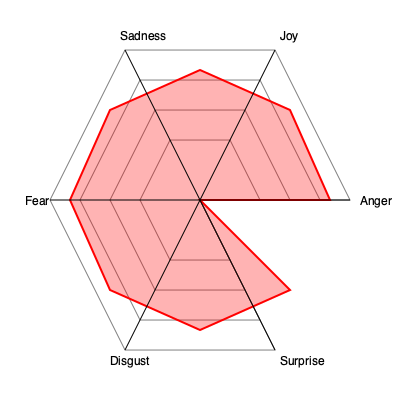Based on the radar chart depicting Kelsey Leigh Miller's emotional range in performances, which emotion does she seem to portray most strongly, and which one appears to be her weakest? To answer this question, we need to analyze the radar chart showing Kelsey Leigh Miller's emotional range in performances:

1. The chart displays six emotions: Anger, Joy, Sadness, Fear, Disgust, and Surprise.
2. Each emotion is represented by an axis extending from the center of the chart.
3. The red polygon indicates the extent of Kelsey's ability to portray each emotion.
4. The further the polygon extends along an axis, the stronger her ability to portray that emotion.

Analyzing the chart:
1. Anger: The polygon extends to the outermost ring, indicating very strong portrayal.
2. Joy: Extends to about 3/4 of the axis, showing good but not maximum ability.
3. Sadness: Reaches almost to the outer ring, indicating strong portrayal.
4. Fear: Extends to about 2/3 of the axis, showing moderate ability.
5. Disgust: Reaches just over halfway, indicating average portrayal.
6. Surprise: Extends to about 3/4 of the axis, similar to Joy.

From this analysis, we can conclude that Anger is Kelsey's strongest emotional portrayal, as it reaches the outermost point on the chart. Conversely, Disgust appears to be her weakest, as it extends the least along its axis.
Answer: Strongest: Anger; Weakest: Disgust 